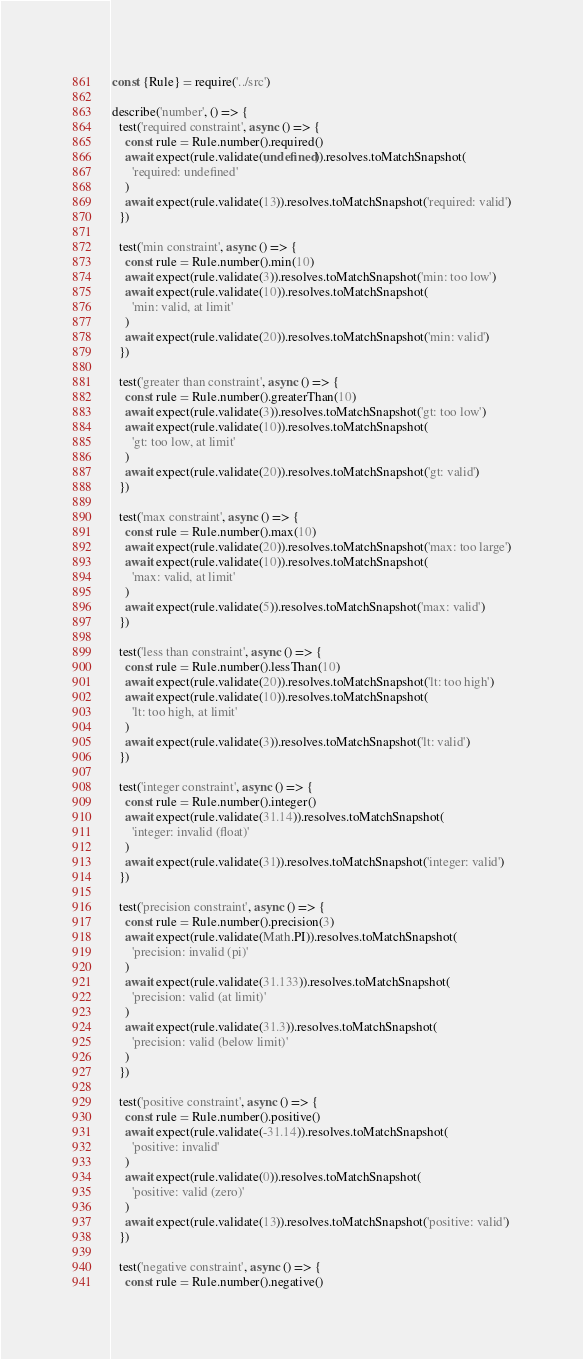Convert code to text. <code><loc_0><loc_0><loc_500><loc_500><_JavaScript_>const {Rule} = require('../src')

describe('number', () => {
  test('required constraint', async () => {
    const rule = Rule.number().required()
    await expect(rule.validate(undefined)).resolves.toMatchSnapshot(
      'required: undefined'
    )
    await expect(rule.validate(13)).resolves.toMatchSnapshot('required: valid')
  })

  test('min constraint', async () => {
    const rule = Rule.number().min(10)
    await expect(rule.validate(3)).resolves.toMatchSnapshot('min: too low')
    await expect(rule.validate(10)).resolves.toMatchSnapshot(
      'min: valid, at limit'
    )
    await expect(rule.validate(20)).resolves.toMatchSnapshot('min: valid')
  })

  test('greater than constraint', async () => {
    const rule = Rule.number().greaterThan(10)
    await expect(rule.validate(3)).resolves.toMatchSnapshot('gt: too low')
    await expect(rule.validate(10)).resolves.toMatchSnapshot(
      'gt: too low, at limit'
    )
    await expect(rule.validate(20)).resolves.toMatchSnapshot('gt: valid')
  })

  test('max constraint', async () => {
    const rule = Rule.number().max(10)
    await expect(rule.validate(20)).resolves.toMatchSnapshot('max: too large')
    await expect(rule.validate(10)).resolves.toMatchSnapshot(
      'max: valid, at limit'
    )
    await expect(rule.validate(5)).resolves.toMatchSnapshot('max: valid')
  })

  test('less than constraint', async () => {
    const rule = Rule.number().lessThan(10)
    await expect(rule.validate(20)).resolves.toMatchSnapshot('lt: too high')
    await expect(rule.validate(10)).resolves.toMatchSnapshot(
      'lt: too high, at limit'
    )
    await expect(rule.validate(3)).resolves.toMatchSnapshot('lt: valid')
  })

  test('integer constraint', async () => {
    const rule = Rule.number().integer()
    await expect(rule.validate(31.14)).resolves.toMatchSnapshot(
      'integer: invalid (float)'
    )
    await expect(rule.validate(31)).resolves.toMatchSnapshot('integer: valid')
  })

  test('precision constraint', async () => {
    const rule = Rule.number().precision(3)
    await expect(rule.validate(Math.PI)).resolves.toMatchSnapshot(
      'precision: invalid (pi)'
    )
    await expect(rule.validate(31.133)).resolves.toMatchSnapshot(
      'precision: valid (at limit)'
    )
    await expect(rule.validate(31.3)).resolves.toMatchSnapshot(
      'precision: valid (below limit)'
    )
  })

  test('positive constraint', async () => {
    const rule = Rule.number().positive()
    await expect(rule.validate(-31.14)).resolves.toMatchSnapshot(
      'positive: invalid'
    )
    await expect(rule.validate(0)).resolves.toMatchSnapshot(
      'positive: valid (zero)'
    )
    await expect(rule.validate(13)).resolves.toMatchSnapshot('positive: valid')
  })

  test('negative constraint', async () => {
    const rule = Rule.number().negative()</code> 